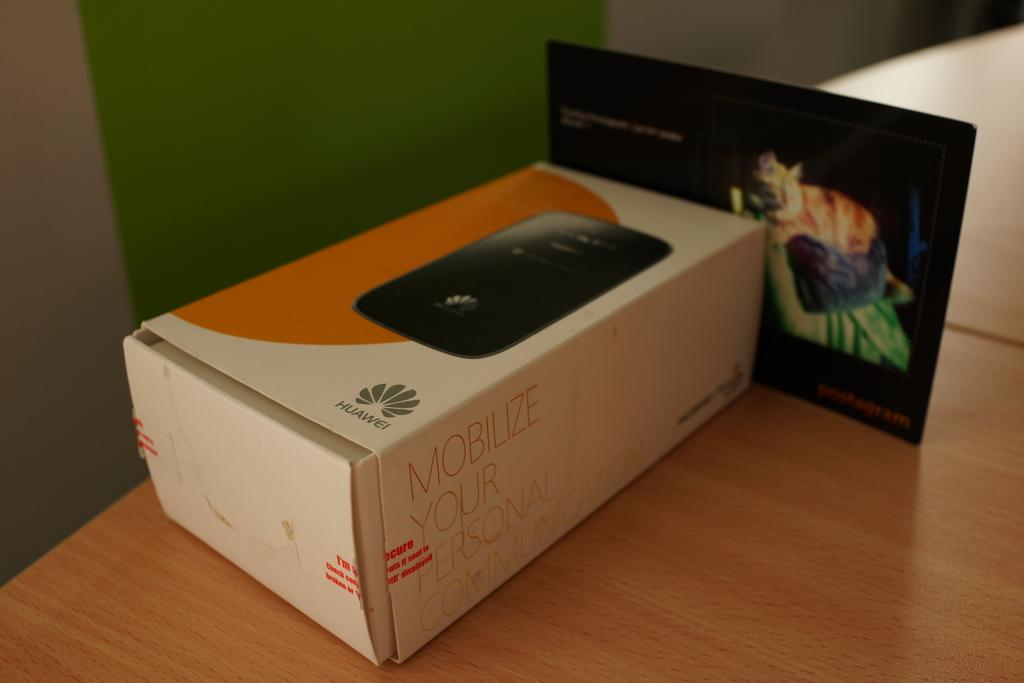<image>
Write a terse but informative summary of the picture. a white phone box that says 'mobile your personal communication' on it in red 